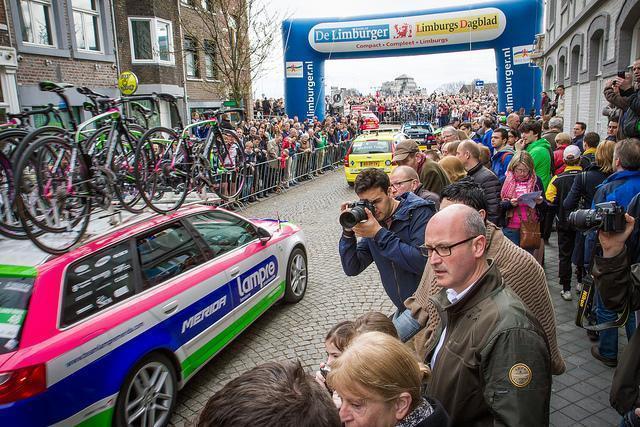What will the man in the blue sweatshirt do next?
Choose the right answer and clarify with the format: 'Answer: answer
Rationale: rationale.'
Options: Take photograph, give object, throw object, eat object. Answer: take photograph.
Rationale: The man is taking a photo. 